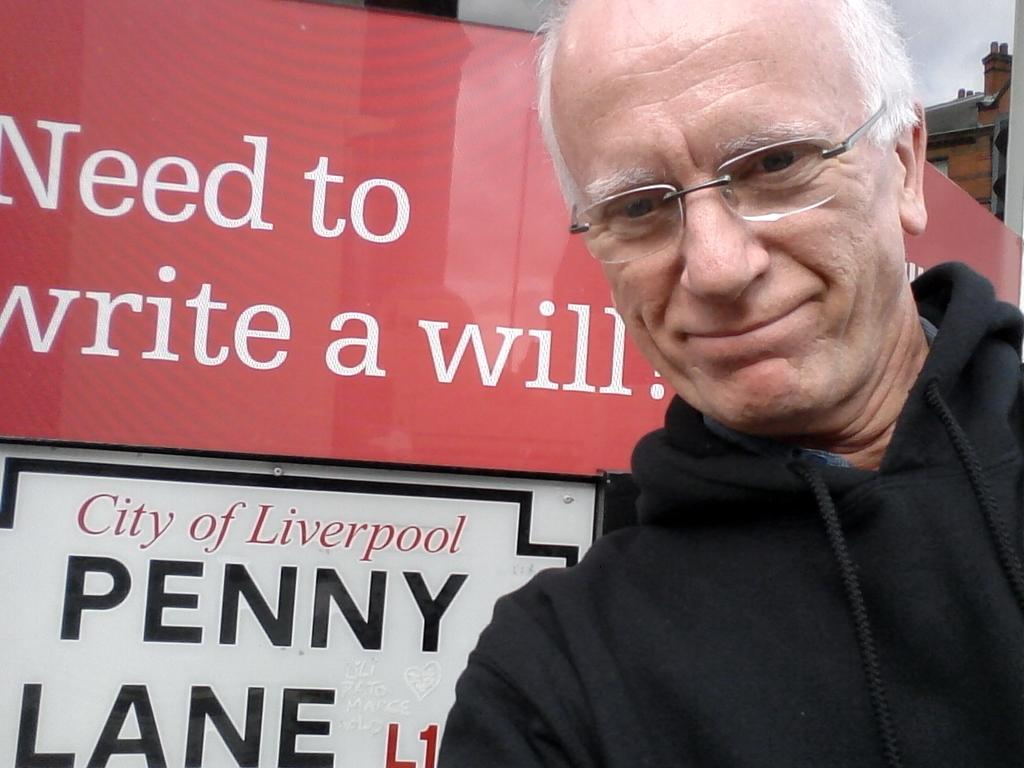What is the appearance of the person in the image? There is an old man in the image, and he has white hair. What is the old man wearing in the image? The old man is wearing a black hoodie. Where is the old man positioned in the image? The old man is standing on the right side of the image. What else can be seen in the image besides the old man? There is a banner in the image. What type of quiver is the old man holding in the image? There is no quiver present in the image; the old man is only wearing a black hoodie. Can you see any bats flying around the old man in the image? There are no bats visible in the image; the old man is standing near a banner. 